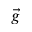Convert formula to latex. <formula><loc_0><loc_0><loc_500><loc_500>\vec { g }</formula> 